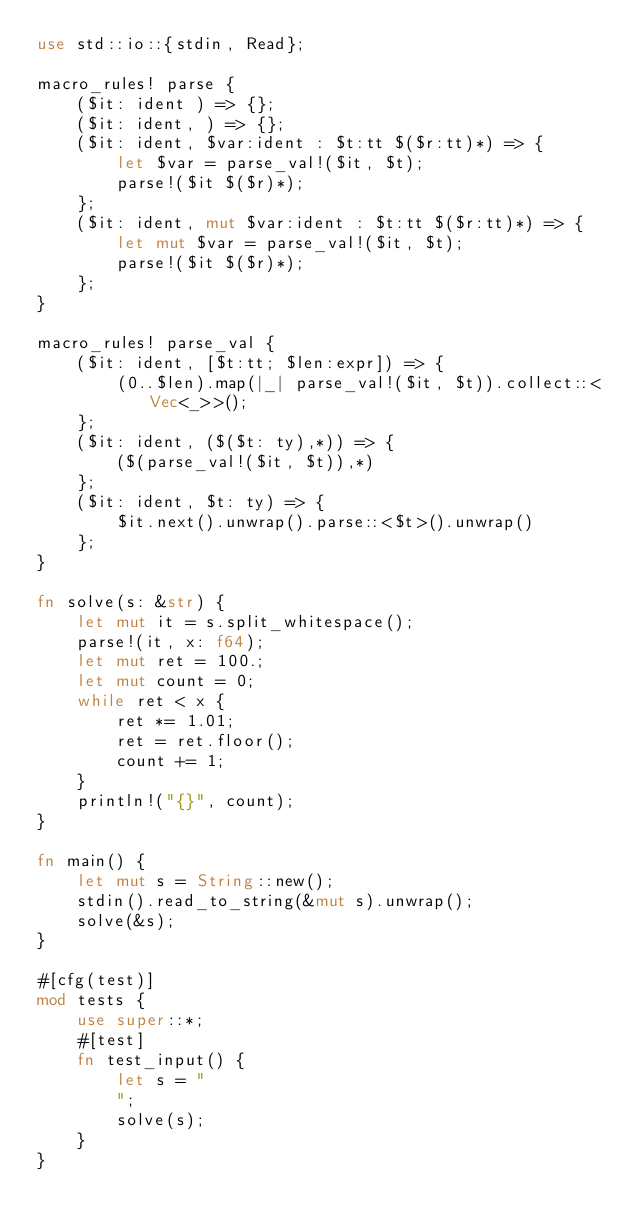<code> <loc_0><loc_0><loc_500><loc_500><_Rust_>use std::io::{stdin, Read};

macro_rules! parse {
    ($it: ident ) => {};
    ($it: ident, ) => {};
    ($it: ident, $var:ident : $t:tt $($r:tt)*) => {
        let $var = parse_val!($it, $t);
        parse!($it $($r)*);
    };
    ($it: ident, mut $var:ident : $t:tt $($r:tt)*) => {
        let mut $var = parse_val!($it, $t);
        parse!($it $($r)*);
    };
}

macro_rules! parse_val {
    ($it: ident, [$t:tt; $len:expr]) => {
        (0..$len).map(|_| parse_val!($it, $t)).collect::<Vec<_>>();
    };
    ($it: ident, ($($t: ty),*)) => {
        ($(parse_val!($it, $t)),*)
    };
    ($it: ident, $t: ty) => {
        $it.next().unwrap().parse::<$t>().unwrap()
    };
}

fn solve(s: &str) {
    let mut it = s.split_whitespace();
    parse!(it, x: f64);
    let mut ret = 100.;
    let mut count = 0;
    while ret < x {
        ret *= 1.01;
        ret = ret.floor();
        count += 1;
    }
    println!("{}", count);
}

fn main() {
    let mut s = String::new();
    stdin().read_to_string(&mut s).unwrap();
    solve(&s);
}

#[cfg(test)]
mod tests {
    use super::*;
    #[test]
    fn test_input() {
        let s = "
        ";
        solve(s);
    }
}
</code> 